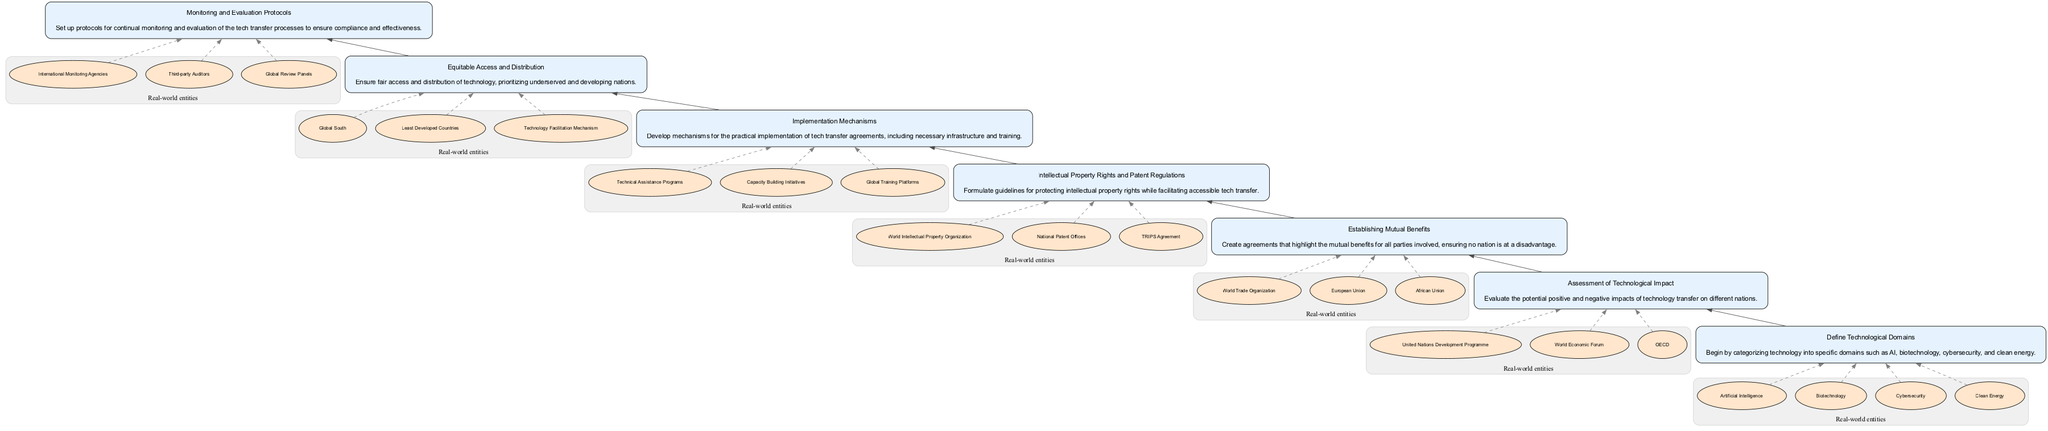What is the first step in the protocol? The first step in the protocol is "Define Technological Domains," which categorizes technology into specific domains.
Answer: Define Technological Domains How many real-world entities are associated with "Intellectual Property Rights and Patent Regulations"? There are three real-world entities associated with this node: World Intellectual Property Organization, National Patent Offices, and TRIPS Agreement.
Answer: 3 What step focuses on ensuring fair access and distribution of technology? The step that focuses on fair access and distribution of technology is "Equitable Access and Distribution."
Answer: Equitable Access and Distribution Which node follows "Establishing Mutual Benefits"? The node that follows "Establishing Mutual Benefits" is "Intellectual Property Rights and Patent Regulations."
Answer: Intellectual Property Rights and Patent Regulations What does the last node in the diagram entail? The last node, "Monitoring and Evaluation Protocols," entails setting up protocols for continual monitoring and evaluation of the tech transfer processes.
Answer: Monitoring and Evaluation Protocols How many total nodes are there in the diagram? There are seven total nodes in the diagram, each representing a different step in the protocol for tech-transfer agreements.
Answer: 7 Which step comes immediately before "Implementation Mechanisms"? The step that comes immediately before "Implementation Mechanisms" is "Intellectual Property Rights and Patent Regulations."
Answer: Intellectual Property Rights and Patent Regulations What is the primary focus of "Assessment of Technological Impact"? The primary focus of this step is to evaluate the potential positive and negative impacts of technology transfer on different nations.
Answer: Evaluate the potential positive and negative impacts In the flow of the diagram, which step directs attention to developing nations? The step that directs attention to developing nations is "Equitable Access and Distribution."
Answer: Equitable Access and Distribution 